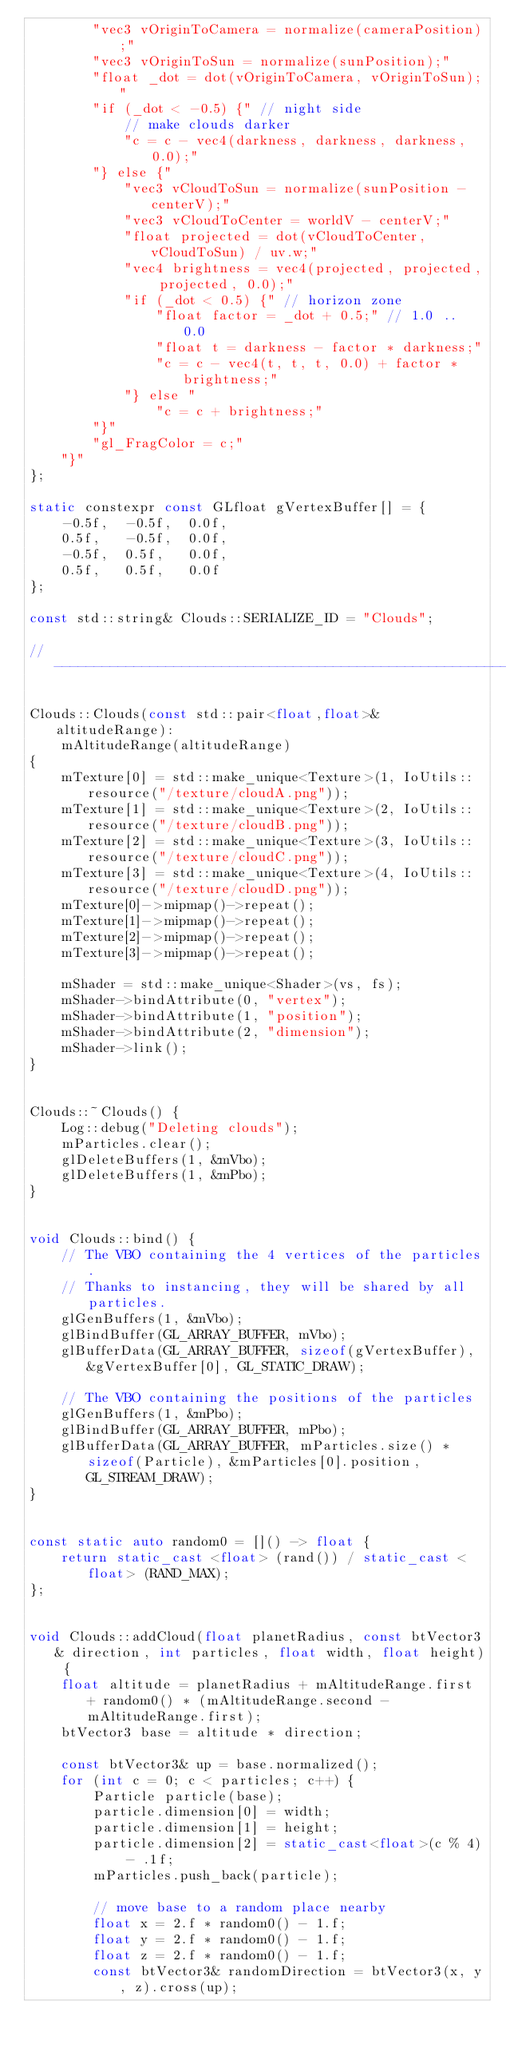Convert code to text. <code><loc_0><loc_0><loc_500><loc_500><_C++_>		"vec3 vOriginToCamera = normalize(cameraPosition);"
		"vec3 vOriginToSun = normalize(sunPosition);"
		"float _dot = dot(vOriginToCamera, vOriginToSun);"
		"if (_dot < -0.5) {" // night side
			// make clouds darker
			"c = c - vec4(darkness, darkness, darkness, 0.0);"
		"} else {"
			"vec3 vCloudToSun = normalize(sunPosition - centerV);"
			"vec3 vCloudToCenter = worldV - centerV;"
			"float projected = dot(vCloudToCenter, vCloudToSun) / uv.w;"
			"vec4 brightness = vec4(projected, projected, projected, 0.0);"
			"if (_dot < 0.5) {" // horizon zone
				"float factor = _dot + 0.5;" // 1.0 .. 0.0
				"float t = darkness - factor * darkness;"
				"c = c - vec4(t, t, t, 0.0) + factor * brightness;"
			"} else "
				"c = c + brightness;"
		"}"
		"gl_FragColor = c;"
	"}"
};

static constexpr const GLfloat gVertexBuffer[] = {
	-0.5f,	-0.5f,	0.0f,
	0.5f,	-0.5f,	0.0f,
	-0.5f,	0.5f,	0.0f,
	0.5f, 	0.5f, 	0.0f
};

const std::string& Clouds::SERIALIZE_ID = "Clouds";

//-----------------------------------------------------------------------------

Clouds::Clouds(const std::pair<float,float>& altitudeRange):
	mAltitudeRange(altitudeRange)
{
	mTexture[0] = std::make_unique<Texture>(1, IoUtils::resource("/texture/cloudA.png"));
	mTexture[1] = std::make_unique<Texture>(2, IoUtils::resource("/texture/cloudB.png"));
	mTexture[2] = std::make_unique<Texture>(3, IoUtils::resource("/texture/cloudC.png"));
	mTexture[3] = std::make_unique<Texture>(4, IoUtils::resource("/texture/cloudD.png"));
	mTexture[0]->mipmap()->repeat();
	mTexture[1]->mipmap()->repeat();
	mTexture[2]->mipmap()->repeat();
	mTexture[3]->mipmap()->repeat();

	mShader = std::make_unique<Shader>(vs, fs);
	mShader->bindAttribute(0, "vertex");
	mShader->bindAttribute(1, "position");
	mShader->bindAttribute(2, "dimension");
	mShader->link();
}


Clouds::~Clouds() {
	Log::debug("Deleting clouds");
	mParticles.clear();
	glDeleteBuffers(1, &mVbo);
	glDeleteBuffers(1, &mPbo);
}


void Clouds::bind() {
	// The VBO containing the 4 vertices of the particles.
	// Thanks to instancing, they will be shared by all particles.
	glGenBuffers(1, &mVbo);
	glBindBuffer(GL_ARRAY_BUFFER, mVbo);
	glBufferData(GL_ARRAY_BUFFER, sizeof(gVertexBuffer), &gVertexBuffer[0], GL_STATIC_DRAW);

	// The VBO containing the positions of the particles
	glGenBuffers(1, &mPbo);
	glBindBuffer(GL_ARRAY_BUFFER, mPbo);
	glBufferData(GL_ARRAY_BUFFER, mParticles.size() * sizeof(Particle), &mParticles[0].position, GL_STREAM_DRAW);
}


const static auto random0 = []() -> float {
	return static_cast <float> (rand()) / static_cast <float> (RAND_MAX);
};


void Clouds::addCloud(float planetRadius, const btVector3& direction, int particles, float width, float height) {
	float altitude = planetRadius + mAltitudeRange.first + random0() * (mAltitudeRange.second - mAltitudeRange.first);
	btVector3 base = altitude * direction;

	const btVector3& up = base.normalized();
	for (int c = 0; c < particles; c++) {
		Particle particle(base);
		particle.dimension[0] = width;
		particle.dimension[1] = height;
		particle.dimension[2] = static_cast<float>(c % 4) - .1f;
		mParticles.push_back(particle);

		// move base to a random place nearby
		float x = 2.f * random0() - 1.f;
		float y = 2.f * random0() - 1.f;
		float z = 2.f * random0() - 1.f;
		const btVector3& randomDirection = btVector3(x, y, z).cross(up);</code> 